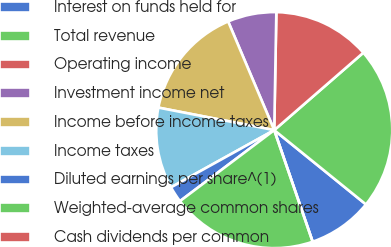Convert chart to OTSL. <chart><loc_0><loc_0><loc_500><loc_500><pie_chart><fcel>Interest on funds held for<fcel>Total revenue<fcel>Operating income<fcel>Investment income net<fcel>Income before income taxes<fcel>Income taxes<fcel>Diluted earnings per share^(1)<fcel>Weighted-average common shares<fcel>Cash dividends per common<nl><fcel>8.89%<fcel>22.22%<fcel>13.33%<fcel>6.67%<fcel>15.56%<fcel>11.11%<fcel>2.22%<fcel>20.0%<fcel>0.0%<nl></chart> 